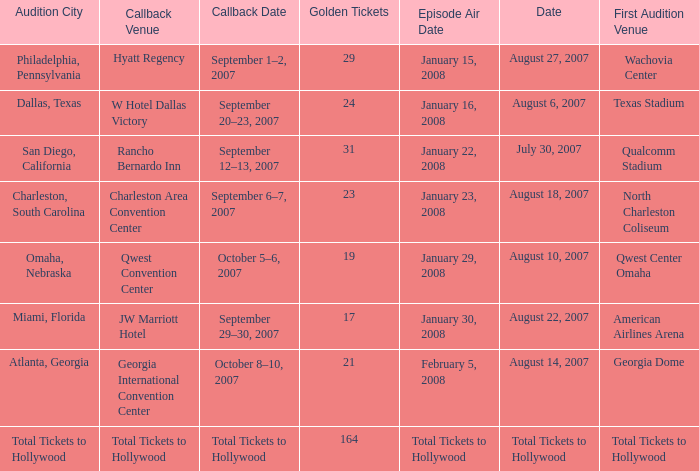How many golden tickets for the georgia international convention center? 21.0. 